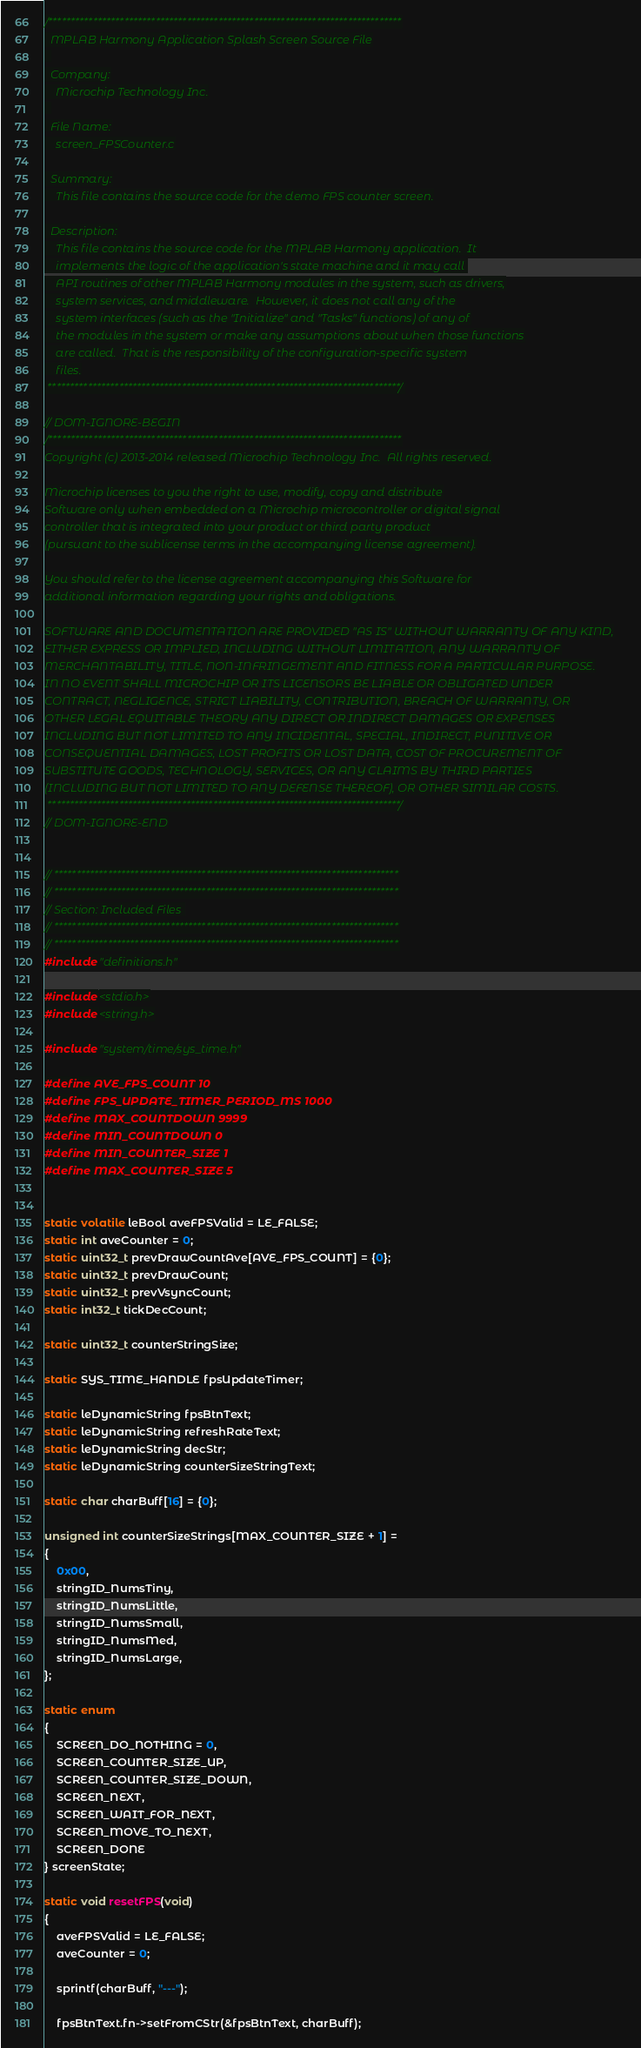Convert code to text. <code><loc_0><loc_0><loc_500><loc_500><_C_>/*******************************************************************************
  MPLAB Harmony Application Splash Screen Source File
  
  Company:
    Microchip Technology Inc.
  
  File Name:
    screen_FPSCounter.c

  Summary:
    This file contains the source code for the demo FPS counter screen.

  Description:
    This file contains the source code for the MPLAB Harmony application.  It 
    implements the logic of the application's state machine and it may call 
    API routines of other MPLAB Harmony modules in the system, such as drivers,
    system services, and middleware.  However, it does not call any of the
    system interfaces (such as the "Initialize" and "Tasks" functions) of any of
    the modules in the system or make any assumptions about when those functions
    are called.  That is the responsibility of the configuration-specific system
    files.
 *******************************************************************************/

// DOM-IGNORE-BEGIN
/*******************************************************************************
Copyright (c) 2013-2014 released Microchip Technology Inc.  All rights reserved.

Microchip licenses to you the right to use, modify, copy and distribute
Software only when embedded on a Microchip microcontroller or digital signal
controller that is integrated into your product or third party product
(pursuant to the sublicense terms in the accompanying license agreement).

You should refer to the license agreement accompanying this Software for
additional information regarding your rights and obligations.

SOFTWARE AND DOCUMENTATION ARE PROVIDED "AS IS" WITHOUT WARRANTY OF ANY KIND,
EITHER EXPRESS OR IMPLIED, INCLUDING WITHOUT LIMITATION, ANY WARRANTY OF
MERCHANTABILITY, TITLE, NON-INFRINGEMENT AND FITNESS FOR A PARTICULAR PURPOSE.
IN NO EVENT SHALL MICROCHIP OR ITS LICENSORS BE LIABLE OR OBLIGATED UNDER
CONTRACT, NEGLIGENCE, STRICT LIABILITY, CONTRIBUTION, BREACH OF WARRANTY, OR
OTHER LEGAL EQUITABLE THEORY ANY DIRECT OR INDIRECT DAMAGES OR EXPENSES
INCLUDING BUT NOT LIMITED TO ANY INCIDENTAL, SPECIAL, INDIRECT, PUNITIVE OR
CONSEQUENTIAL DAMAGES, LOST PROFITS OR LOST DATA, COST OF PROCUREMENT OF
SUBSTITUTE GOODS, TECHNOLOGY, SERVICES, OR ANY CLAIMS BY THIRD PARTIES
(INCLUDING BUT NOT LIMITED TO ANY DEFENSE THEREOF), OR OTHER SIMILAR COSTS.
 *******************************************************************************/
// DOM-IGNORE-END


// *****************************************************************************
// *****************************************************************************
// Section: Included Files 
// *****************************************************************************
// *****************************************************************************
#include "definitions.h"

#include <stdio.h>
#include <string.h>

#include "system/time/sys_time.h"

#define AVE_FPS_COUNT 10
#define FPS_UPDATE_TIMER_PERIOD_MS 1000
#define MAX_COUNTDOWN 9999
#define MIN_COUNTDOWN 0
#define MIN_COUNTER_SIZE 1
#define MAX_COUNTER_SIZE 5


static volatile leBool aveFPSValid = LE_FALSE;
static int aveCounter = 0;
static uint32_t prevDrawCountAve[AVE_FPS_COUNT] = {0};
static uint32_t prevDrawCount;
static uint32_t prevVsyncCount;
static int32_t tickDecCount;

static uint32_t counterStringSize; 

static SYS_TIME_HANDLE fpsUpdateTimer;

static leDynamicString fpsBtnText;
static leDynamicString refreshRateText;
static leDynamicString decStr;
static leDynamicString counterSizeStringText;

static char charBuff[16] = {0};

unsigned int counterSizeStrings[MAX_COUNTER_SIZE + 1] =
{
    0x00,
    stringID_NumsTiny,
    stringID_NumsLittle,
    stringID_NumsSmall,
    stringID_NumsMed,
    stringID_NumsLarge,
};

static enum
{
    SCREEN_DO_NOTHING = 0,
    SCREEN_COUNTER_SIZE_UP,
    SCREEN_COUNTER_SIZE_DOWN,
    SCREEN_NEXT,
    SCREEN_WAIT_FOR_NEXT,
    SCREEN_MOVE_TO_NEXT,
    SCREEN_DONE
} screenState;

static void resetFPS(void)
{
    aveFPSValid = LE_FALSE;
    aveCounter = 0;
    
    sprintf(charBuff, "---");
    
    fpsBtnText.fn->setFromCStr(&fpsBtnText, charBuff);</code> 